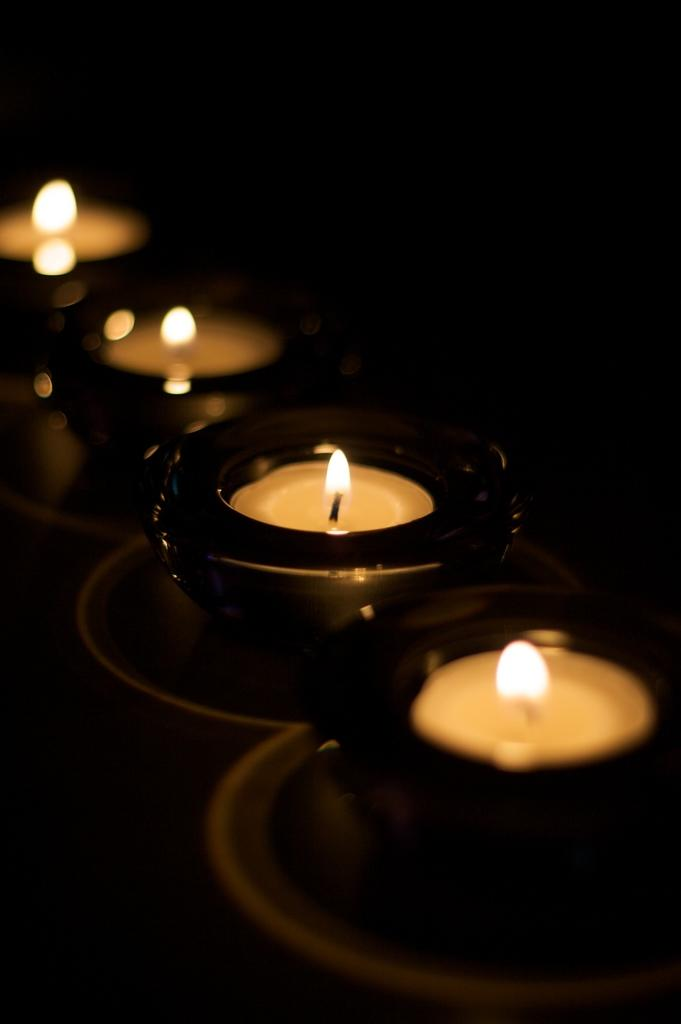What objects in the image have flames? There are candles with flames in the image. What can be observed about the lighting in the image? The background of the image is dark. What type of support does the governor provide in the image? There is no governor present in the image, so it is not possible to answer that question. 